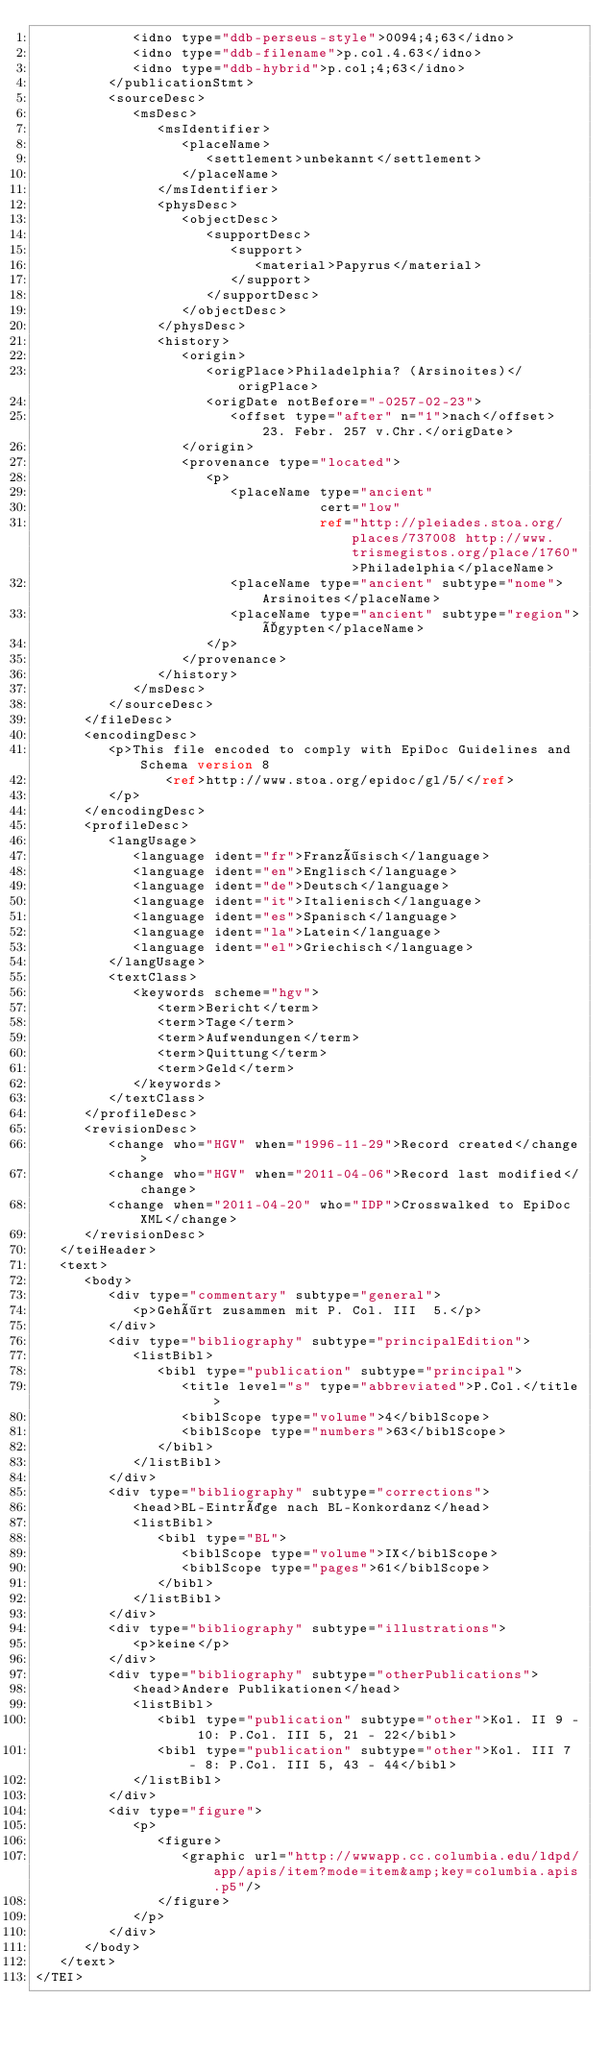Convert code to text. <code><loc_0><loc_0><loc_500><loc_500><_XML_>            <idno type="ddb-perseus-style">0094;4;63</idno>
            <idno type="ddb-filename">p.col.4.63</idno>
            <idno type="ddb-hybrid">p.col;4;63</idno>
         </publicationStmt>
         <sourceDesc>
            <msDesc>
               <msIdentifier>
                  <placeName>
                     <settlement>unbekannt</settlement>
                  </placeName>
               </msIdentifier>
               <physDesc>
                  <objectDesc>
                     <supportDesc>
                        <support>
                           <material>Papyrus</material>
                        </support>
                     </supportDesc>
                  </objectDesc>
               </physDesc>
               <history>
                  <origin>
                     <origPlace>Philadelphia? (Arsinoites)</origPlace>
                     <origDate notBefore="-0257-02-23">
                        <offset type="after" n="1">nach</offset> 23. Febr. 257 v.Chr.</origDate>
                  </origin>
                  <provenance type="located">
                     <p>
                        <placeName type="ancient"
                                   cert="low"
                                   ref="http://pleiades.stoa.org/places/737008 http://www.trismegistos.org/place/1760">Philadelphia</placeName>
                        <placeName type="ancient" subtype="nome">Arsinoites</placeName>
                        <placeName type="ancient" subtype="region">Ägypten</placeName>
                     </p>
                  </provenance>
               </history>
            </msDesc>
         </sourceDesc>
      </fileDesc>
      <encodingDesc>
         <p>This file encoded to comply with EpiDoc Guidelines and Schema version 8
                <ref>http://www.stoa.org/epidoc/gl/5/</ref>
         </p>
      </encodingDesc>
      <profileDesc>
         <langUsage>
            <language ident="fr">Französisch</language>
            <language ident="en">Englisch</language>
            <language ident="de">Deutsch</language>
            <language ident="it">Italienisch</language>
            <language ident="es">Spanisch</language>
            <language ident="la">Latein</language>
            <language ident="el">Griechisch</language>
         </langUsage>
         <textClass>
            <keywords scheme="hgv">
               <term>Bericht</term>
               <term>Tage</term>
               <term>Aufwendungen</term>
               <term>Quittung</term>
               <term>Geld</term>
            </keywords>
         </textClass>
      </profileDesc>
      <revisionDesc>
         <change who="HGV" when="1996-11-29">Record created</change>
         <change who="HGV" when="2011-04-06">Record last modified</change>
         <change when="2011-04-20" who="IDP">Crosswalked to EpiDoc XML</change>
      </revisionDesc>
   </teiHeader>
   <text>
      <body>
         <div type="commentary" subtype="general">
            <p>Gehört zusammen mit P. Col. III  5.</p>
         </div>
         <div type="bibliography" subtype="principalEdition">
            <listBibl>
               <bibl type="publication" subtype="principal">
                  <title level="s" type="abbreviated">P.Col.</title>
                  <biblScope type="volume">4</biblScope>
                  <biblScope type="numbers">63</biblScope>
               </bibl>
            </listBibl>
         </div>
         <div type="bibliography" subtype="corrections">
            <head>BL-Einträge nach BL-Konkordanz</head>
            <listBibl>
               <bibl type="BL">
                  <biblScope type="volume">IX</biblScope>
                  <biblScope type="pages">61</biblScope>
               </bibl>
            </listBibl>
         </div>
         <div type="bibliography" subtype="illustrations">
            <p>keine</p>
         </div>
         <div type="bibliography" subtype="otherPublications">
            <head>Andere Publikationen</head>
            <listBibl>
               <bibl type="publication" subtype="other">Kol. II 9 - 10: P.Col. III 5, 21 - 22</bibl>
               <bibl type="publication" subtype="other">Kol. III 7 - 8: P.Col. III 5, 43 - 44</bibl>
            </listBibl>
         </div>
         <div type="figure">
            <p>
               <figure>
                  <graphic url="http://wwwapp.cc.columbia.edu/ldpd/app/apis/item?mode=item&amp;key=columbia.apis.p5"/>
               </figure>
            </p>
         </div>
      </body>
   </text>
</TEI>
</code> 